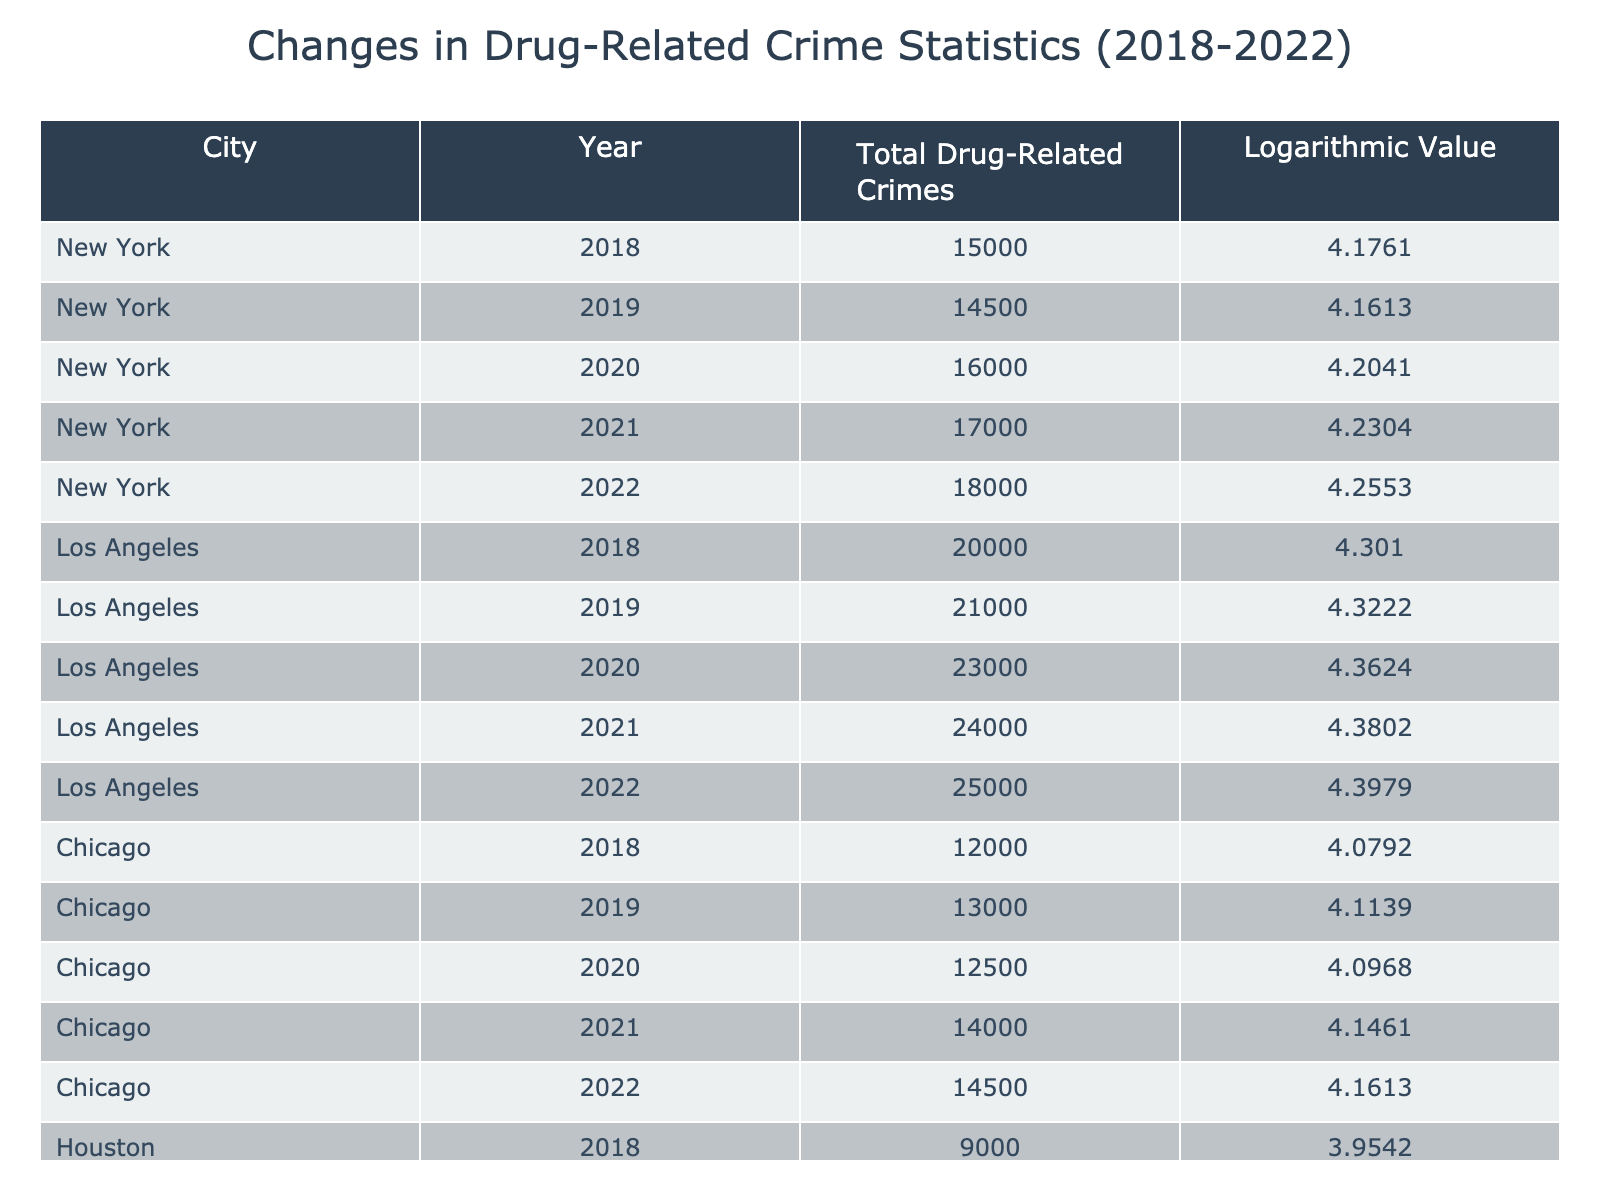What was the total number of drug-related crimes in New York in 2020? The table shows that in New York in 2020, the total number of drug-related crimes was directly listed as 16,000.
Answer: 16,000 Which city had the highest total drug-related crimes in 2019? By comparing the 2019 values for each city in the table, Los Angeles had a total of 21,000 drug-related crimes, which is higher than the other cities listed (New York had 14,500 and Chicago had 13,000).
Answer: Los Angeles What is the change in total drug-related crimes in Chicago from 2018 to 2022? In Chicago, the total number of drug-related crimes in 2018 was 12,000 and in 2022 it was 14,500. The change is calculated as 14,500 - 12,000 = 2,500.
Answer: 2,500 Did Houston show an increase in drug-related crimes every year from 2018 to 2022? Reviewing the yearly total for Houston, the numbers are 9,000 in 2018, 9,500 in 2019, 10,000 in 2020, 11,000 in 2021, and 11,500 in 2022 which indicates an annual increase each year.
Answer: Yes What was the average total drug-related crimes in Los Angeles over the years 2018 to 2022? Adding the total drug-related crimes for Los Angeles from 2018 (20,000), 2019 (21,000), 2020 (23,000), 2021 (24,000), and 2022 (25,000) gives a total of 113,000. The average is calculated as 113,000 divided by 5, which equals 22,600.
Answer: 22,600 What is the difference in the logarithmic value of total drug-related crimes between New York in 2018 and Los Angeles in 2022? In 2018, New York's logarithmic value was 4.1761 and for Los Angeles in 2022 it was 4.3979. The difference is 4.3979 - 4.1761 = 0.2218.
Answer: 0.2218 In which year did Chicago have its highest recorded drug-related crimes? By looking at the total number of drug-related crimes for each year in Chicago, the highest recorded was 14,000 in 2021.
Answer: 2021 Which city had the lowest total drug-related crimes in 2018? Reviewing the totals for 2018, Houston had the lowest total drug-related crimes at 9,000, compared to New York's 15,000, Los Angeles' 20,000, and Chicago's 12,000.
Answer: Houston What is the total sum of drug-related crimes across all cities in the year 2021? In 2021, the totals were New York (17,000), Los Angeles (24,000), Chicago (14,000), and Houston (11,000). Summing them, we get 17,000 + 24,000 + 14,000 + 11,000 = 66,000.
Answer: 66,000 